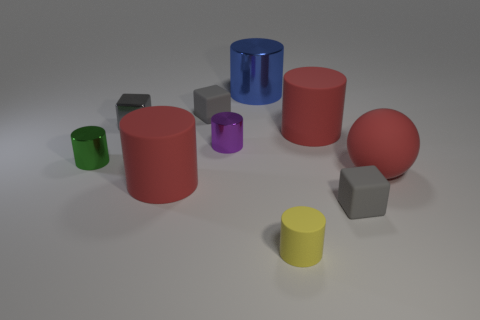Subtract all gray cubes. How many were subtracted if there are1gray cubes left? 2 Subtract all green cubes. How many red cylinders are left? 2 Subtract all blue cylinders. How many cylinders are left? 5 Subtract all tiny gray matte cubes. How many cubes are left? 1 Subtract 1 cylinders. How many cylinders are left? 5 Subtract all cyan cylinders. Subtract all purple spheres. How many cylinders are left? 6 Subtract all balls. How many objects are left? 9 Subtract all tiny gray objects. Subtract all small gray matte objects. How many objects are left? 5 Add 7 yellow matte cylinders. How many yellow matte cylinders are left? 8 Add 6 large red rubber balls. How many large red rubber balls exist? 7 